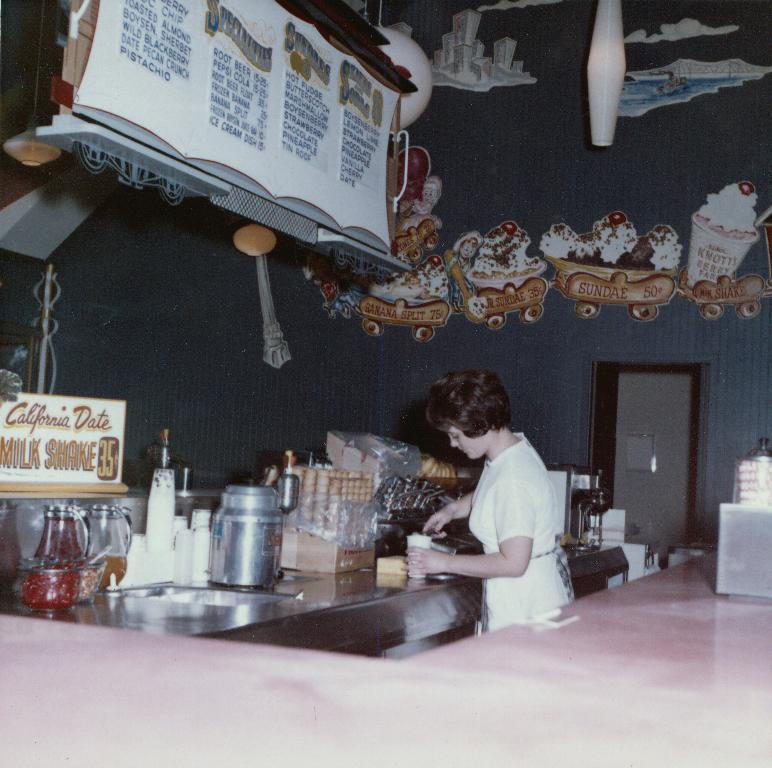Who is the person in the image? There is a woman in the image. What is the woman doing in the image? The woman is making ice cream. What equipment is being used to make the ice cream? There is an ice cream machine in the image. What are the ice cream cones used for? The ice cream cones are used to serve the ice cream. What can be seen in the flavor jar? The flavor jar contains different ice cream flavors. What is the purpose of the cloth in the image? The cloth might be used for cleaning or wiping. What is the menu used for? The menu is likely used to display ice cream flavors or other items available. What type of door is visible in the image? There is no door present in the image. Is the woman sitting on a throne while making ice cream? No, the woman is not sitting on a throne; she is standing near the ice cream machine. 